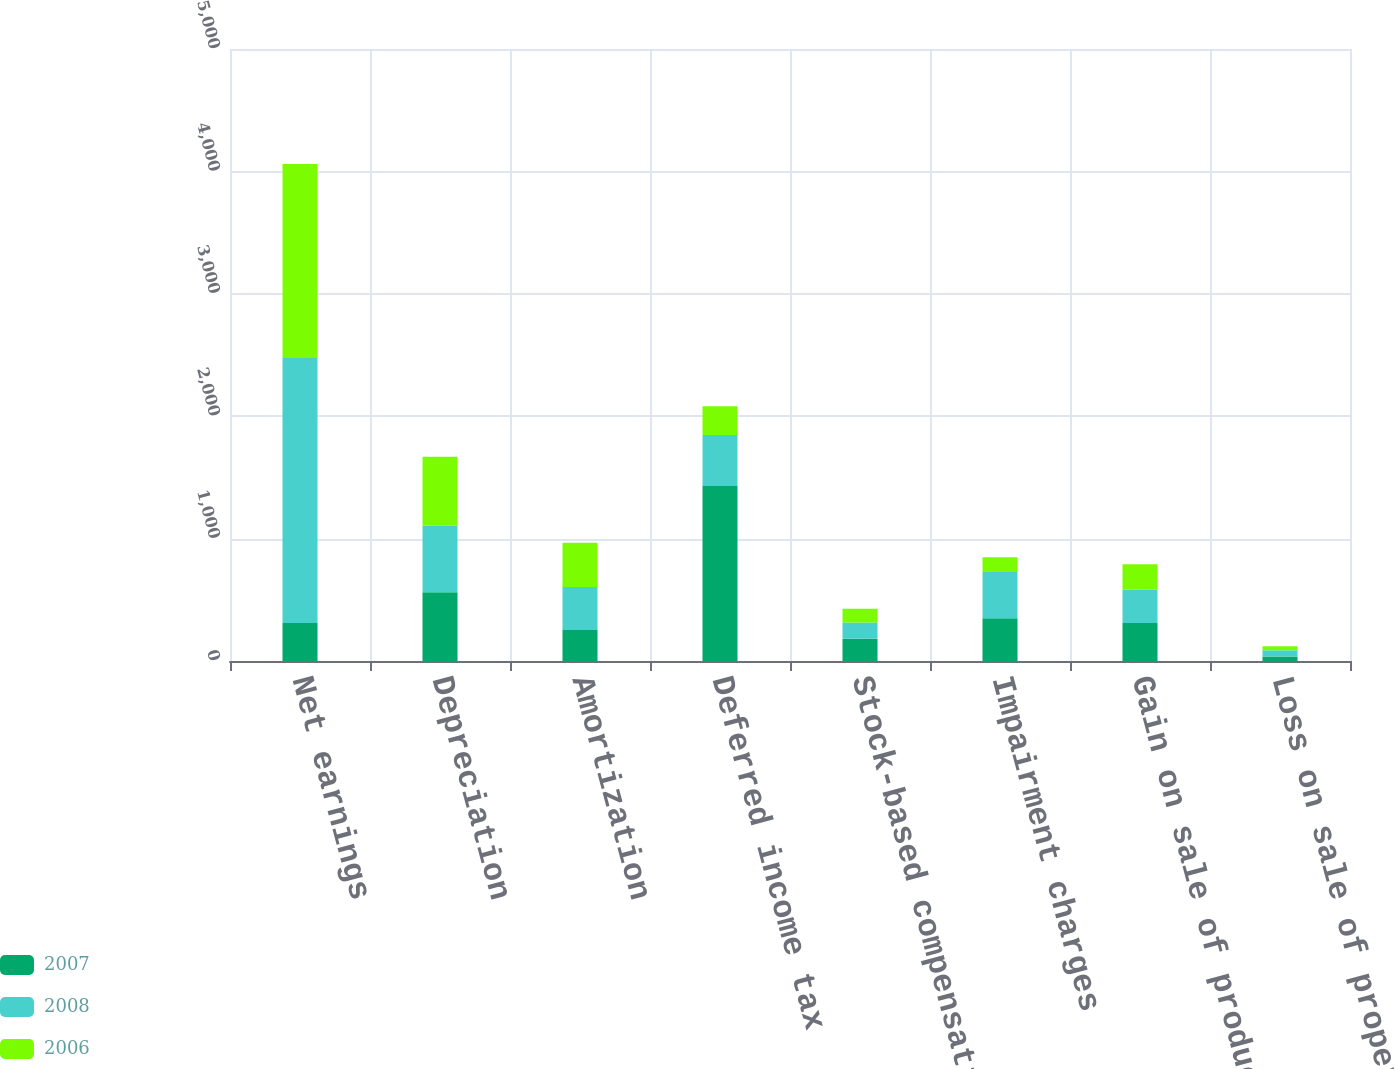Convert chart to OTSL. <chart><loc_0><loc_0><loc_500><loc_500><stacked_bar_chart><ecel><fcel>Net earnings<fcel>Depreciation<fcel>Amortization<fcel>Deferred income tax<fcel>Stock-based compensation<fcel>Impairment charges<fcel>Gain on sale of product lines<fcel>Loss on sale of property plant<nl><fcel>2007<fcel>311<fcel>562<fcel>254<fcel>1430<fcel>181<fcel>349<fcel>311<fcel>36<nl><fcel>2008<fcel>2165<fcel>542<fcel>350<fcel>416<fcel>133<fcel>379<fcel>273<fcel>51<nl><fcel>2006<fcel>1585<fcel>564<fcel>363<fcel>236<fcel>112<fcel>120<fcel>207<fcel>33<nl></chart> 